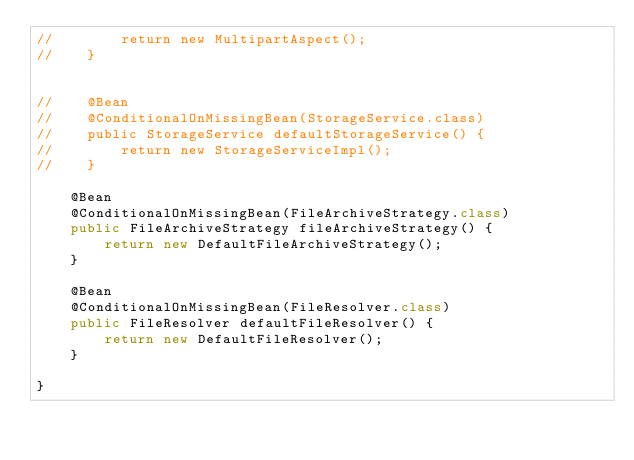Convert code to text. <code><loc_0><loc_0><loc_500><loc_500><_Java_>//        return new MultipartAspect();
//    }


//    @Bean
//    @ConditionalOnMissingBean(StorageService.class)
//    public StorageService defaultStorageService() {
//        return new StorageServiceImpl();
//    }

    @Bean
    @ConditionalOnMissingBean(FileArchiveStrategy.class)
    public FileArchiveStrategy fileArchiveStrategy() {
        return new DefaultFileArchiveStrategy();
    }

    @Bean
    @ConditionalOnMissingBean(FileResolver.class)
    public FileResolver defaultFileResolver() {
        return new DefaultFileResolver();
    }

}
</code> 